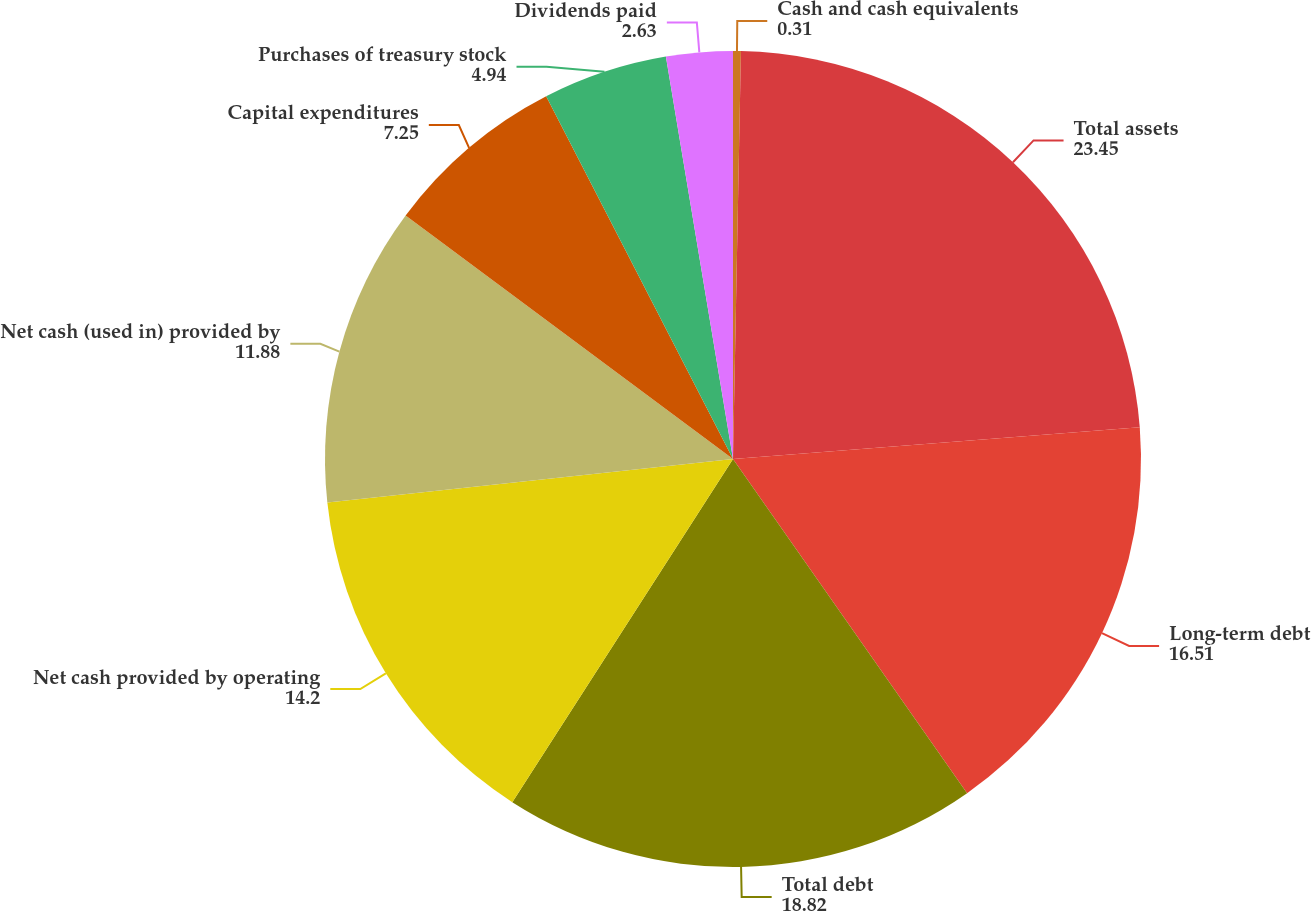Convert chart to OTSL. <chart><loc_0><loc_0><loc_500><loc_500><pie_chart><fcel>Cash and cash equivalents<fcel>Total assets<fcel>Long-term debt<fcel>Total debt<fcel>Net cash provided by operating<fcel>Net cash (used in) provided by<fcel>Capital expenditures<fcel>Purchases of treasury stock<fcel>Dividends paid<nl><fcel>0.31%<fcel>23.45%<fcel>16.51%<fcel>18.82%<fcel>14.2%<fcel>11.88%<fcel>7.25%<fcel>4.94%<fcel>2.63%<nl></chart> 